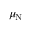Convert formula to latex. <formula><loc_0><loc_0><loc_500><loc_500>\mu _ { N }</formula> 